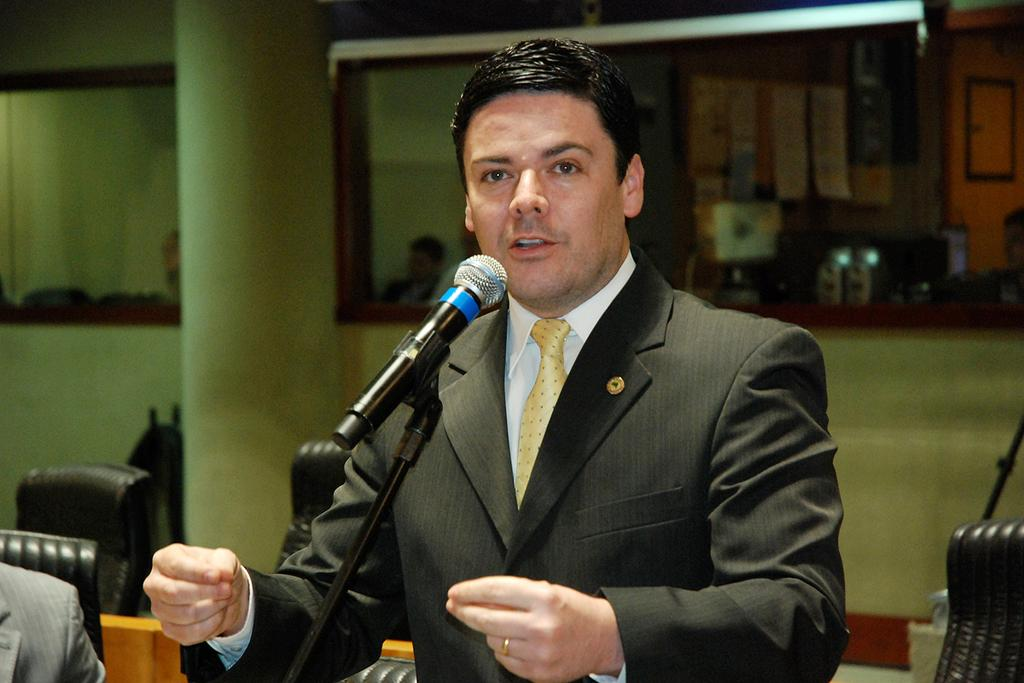What is the man in the image wearing? The man is wearing a blazer and a tie. What is the man doing in the image? The man is talking on a microphone. What can be seen in the background of the image? There are chairs, a pillar, mirrors, and other persons in the background of the image. How many snakes are wrapped around the microphone in the image? There are no snakes present in the image. What emotion is the man expressing while talking on the microphone? The image does not provide information about the man's emotions, so we cannot determine his emotional state from the image. 